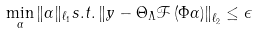Convert formula to latex. <formula><loc_0><loc_0><loc_500><loc_500>\min _ { \alpha } \| \alpha \| _ { \ell _ { 1 } } s . t . \left \| y - { \Theta } _ { \Lambda } \mathcal { F } \left ( { \Phi } \alpha \right ) \right \| _ { \ell _ { 2 } } \leq \epsilon</formula> 